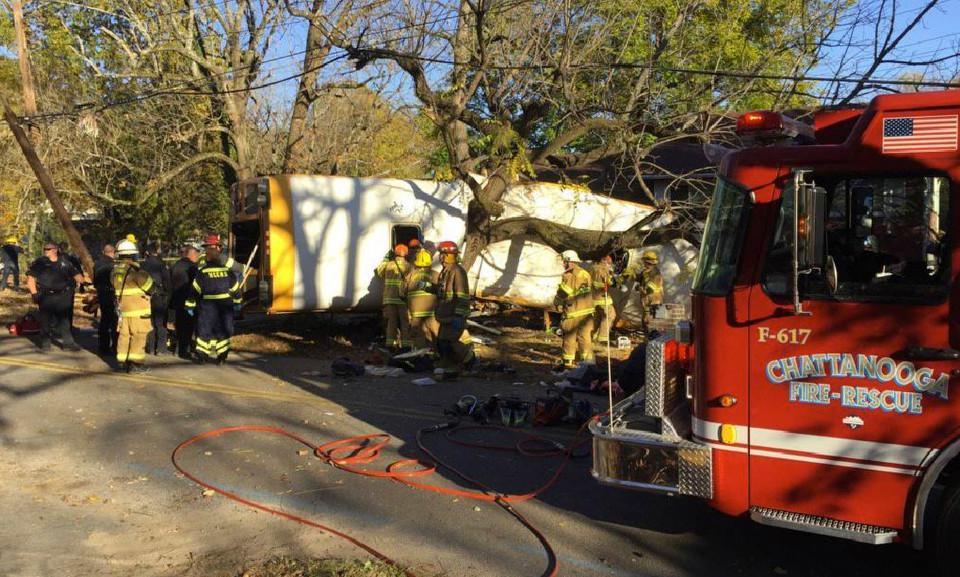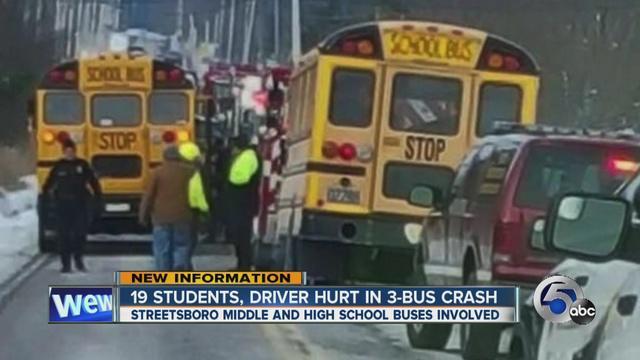The first image is the image on the left, the second image is the image on the right. For the images shown, is this caption "There is 2 school busses shown." true? Answer yes or no. No. The first image is the image on the left, the second image is the image on the right. Considering the images on both sides, is "News headline is visible at bottom of photo for at least one image." valid? Answer yes or no. Yes. 